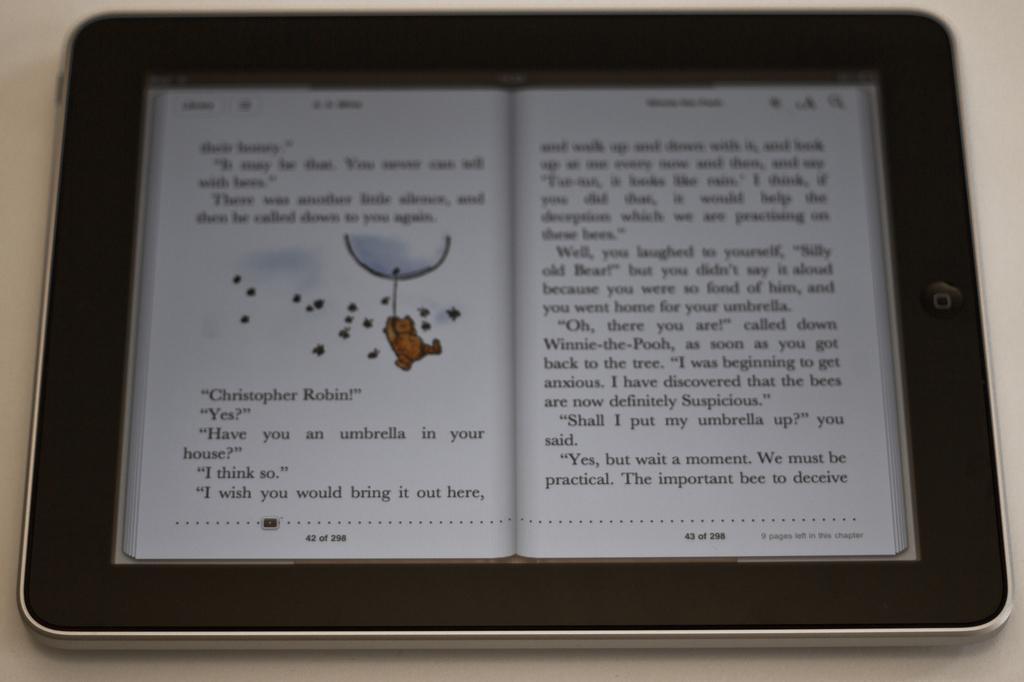<image>
Share a concise interpretation of the image provided. the name Christopher is on the left page of the book 